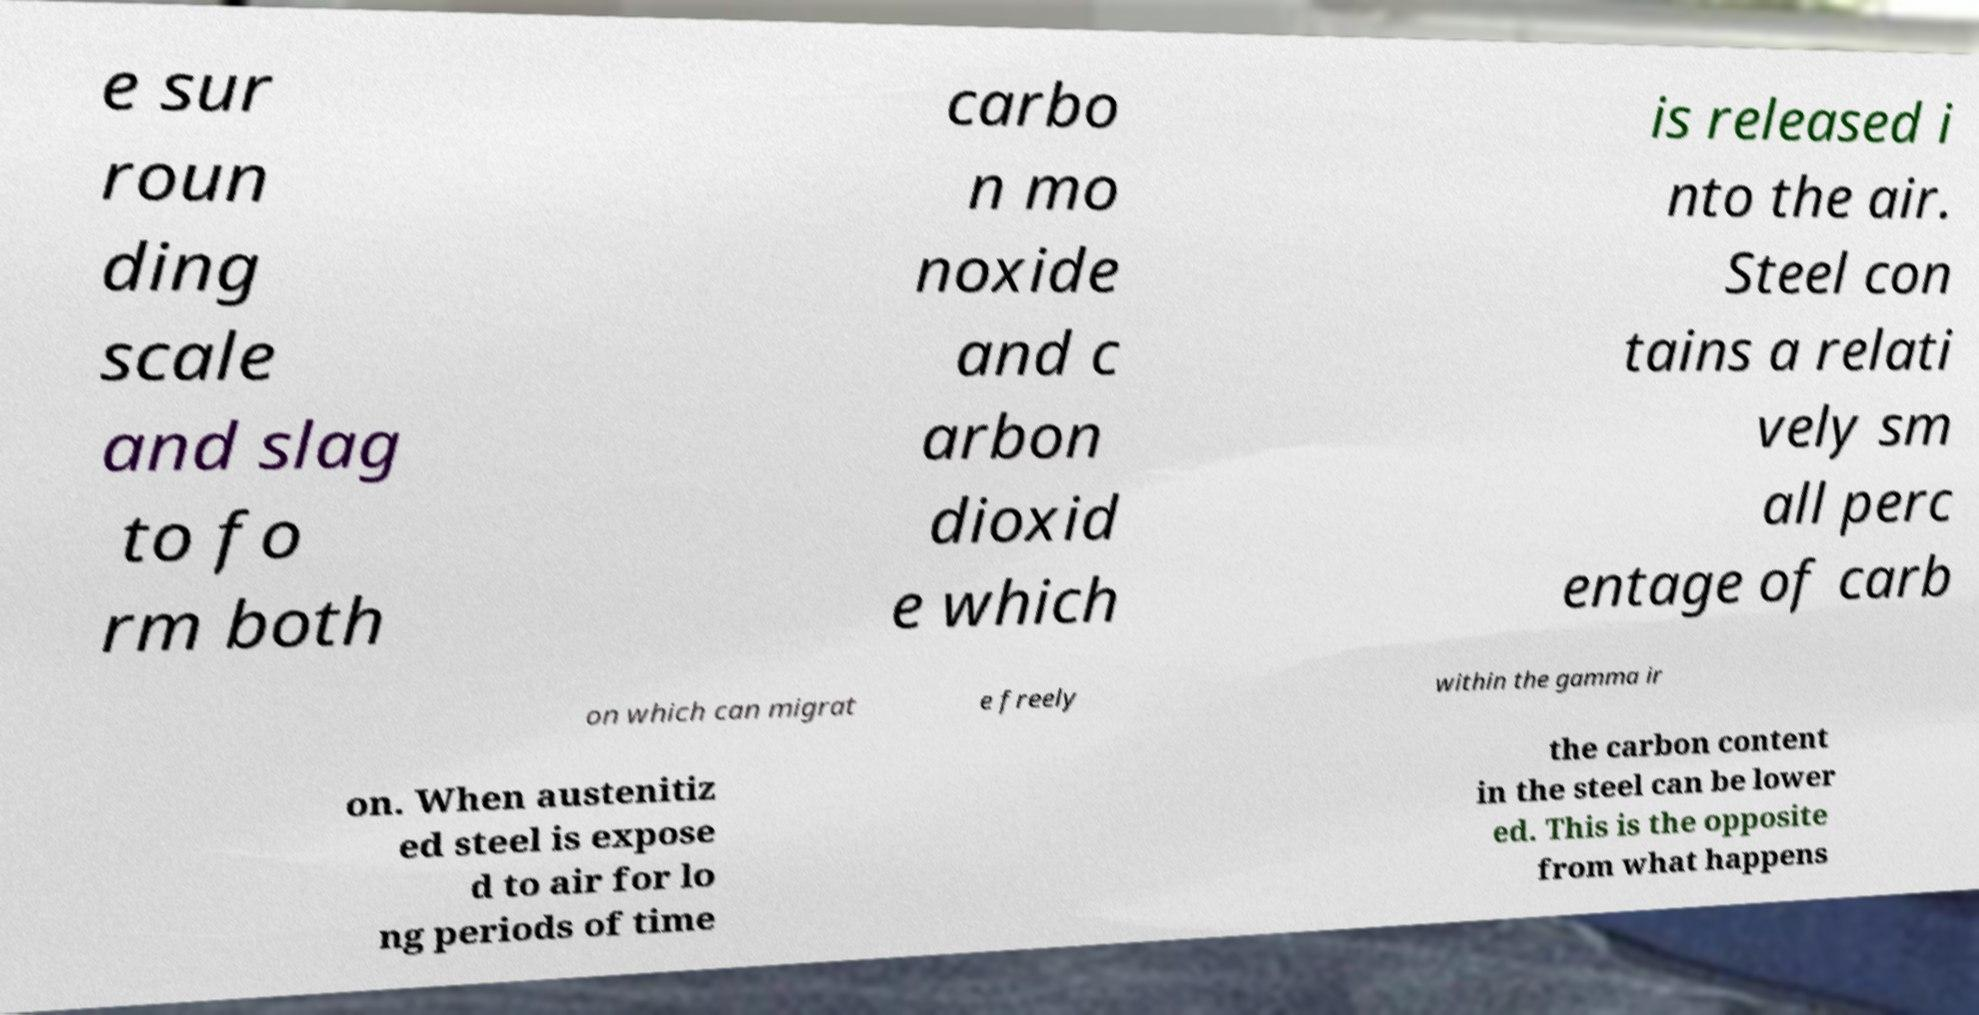Can you accurately transcribe the text from the provided image for me? e sur roun ding scale and slag to fo rm both carbo n mo noxide and c arbon dioxid e which is released i nto the air. Steel con tains a relati vely sm all perc entage of carb on which can migrat e freely within the gamma ir on. When austenitiz ed steel is expose d to air for lo ng periods of time the carbon content in the steel can be lower ed. This is the opposite from what happens 